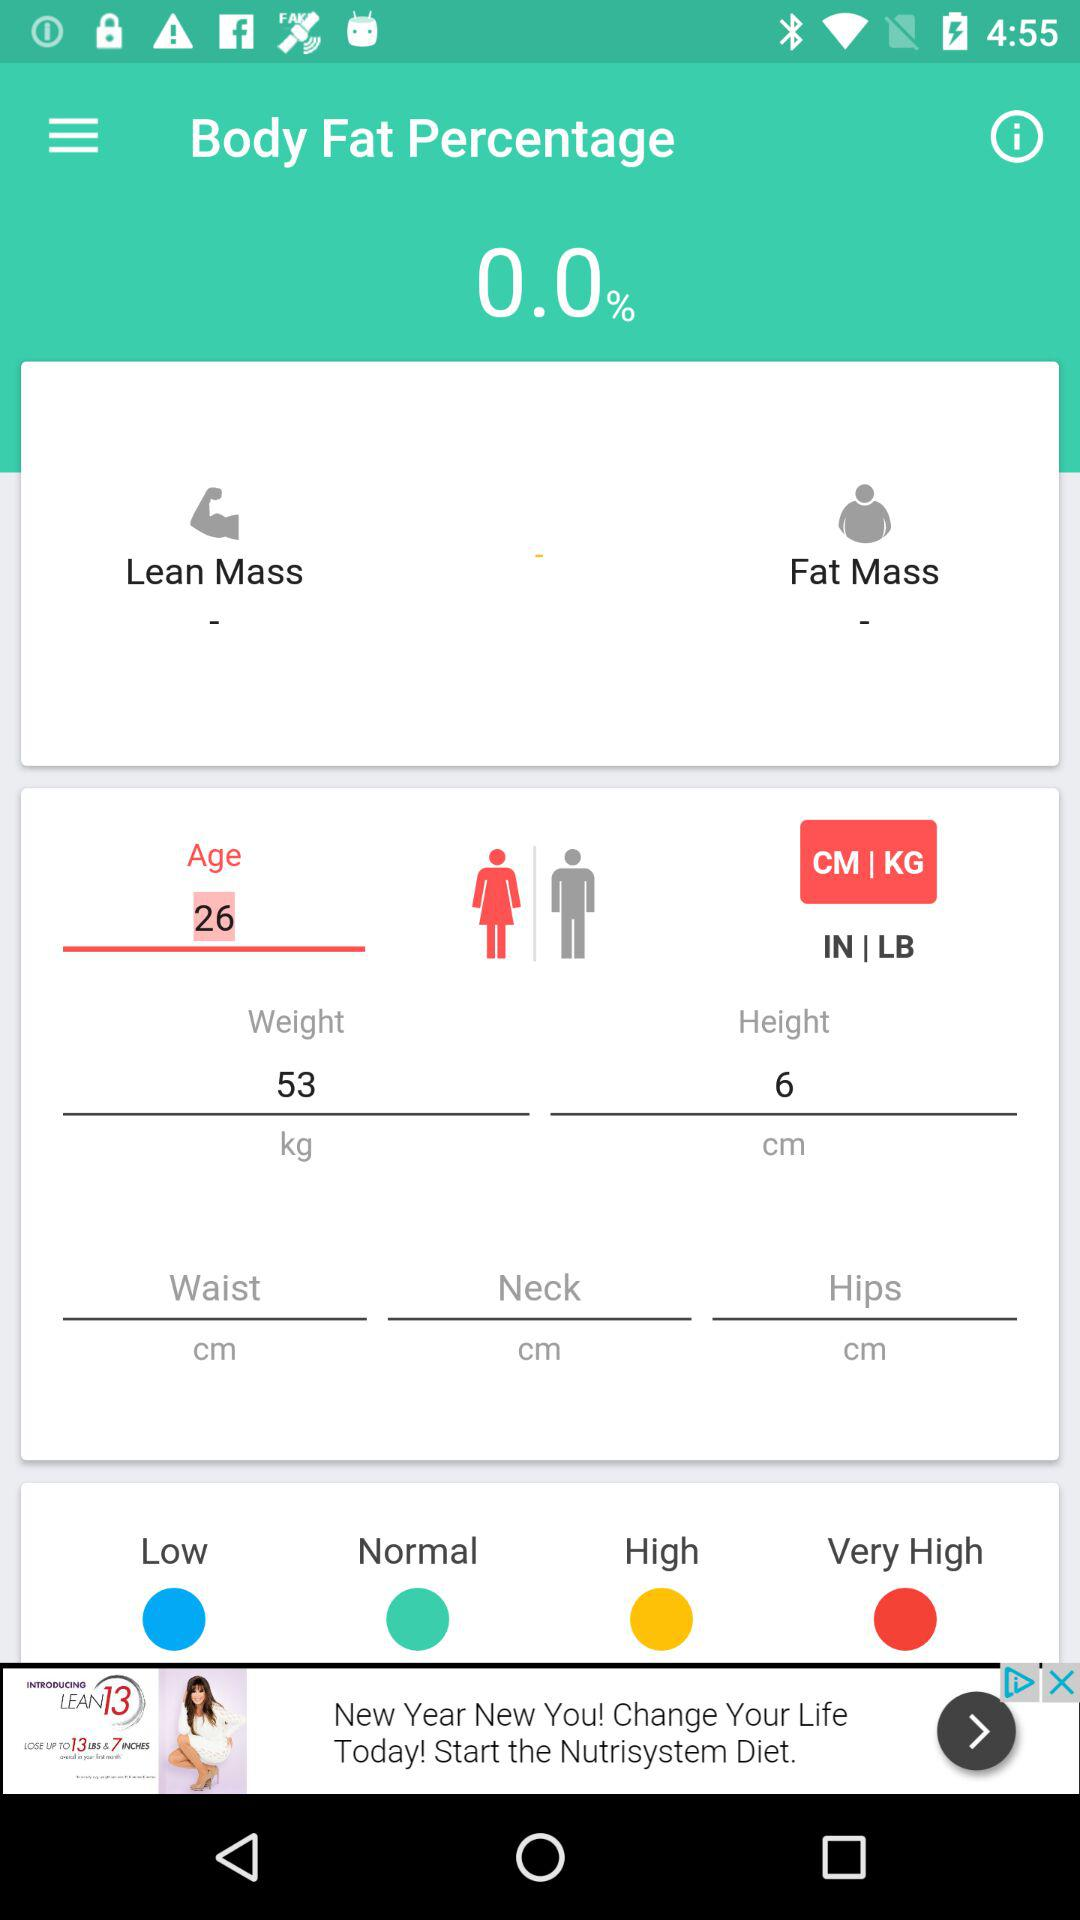What is the mentioned height? The mentioned height is 6 cm. 